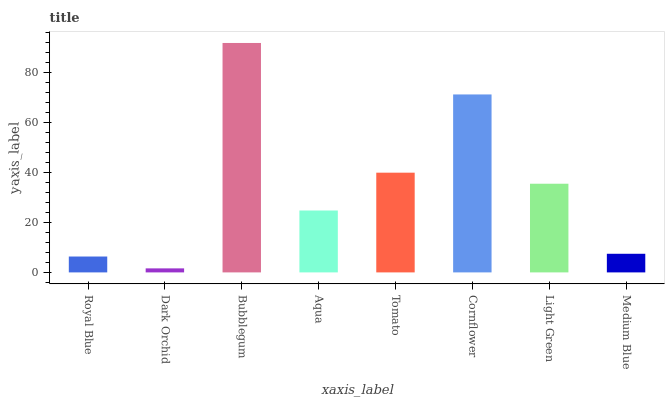Is Dark Orchid the minimum?
Answer yes or no. Yes. Is Bubblegum the maximum?
Answer yes or no. Yes. Is Bubblegum the minimum?
Answer yes or no. No. Is Dark Orchid the maximum?
Answer yes or no. No. Is Bubblegum greater than Dark Orchid?
Answer yes or no. Yes. Is Dark Orchid less than Bubblegum?
Answer yes or no. Yes. Is Dark Orchid greater than Bubblegum?
Answer yes or no. No. Is Bubblegum less than Dark Orchid?
Answer yes or no. No. Is Light Green the high median?
Answer yes or no. Yes. Is Aqua the low median?
Answer yes or no. Yes. Is Tomato the high median?
Answer yes or no. No. Is Medium Blue the low median?
Answer yes or no. No. 